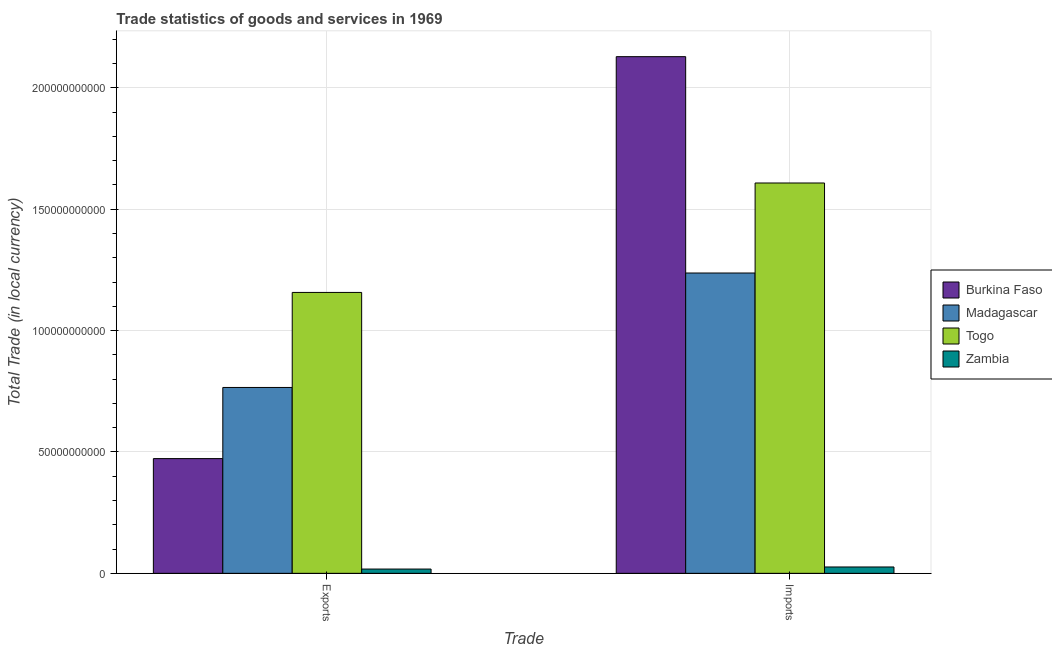How many different coloured bars are there?
Provide a succinct answer. 4. How many groups of bars are there?
Your answer should be compact. 2. How many bars are there on the 2nd tick from the left?
Give a very brief answer. 4. What is the label of the 2nd group of bars from the left?
Make the answer very short. Imports. What is the export of goods and services in Zambia?
Give a very brief answer. 1.76e+09. Across all countries, what is the maximum export of goods and services?
Give a very brief answer. 1.16e+11. Across all countries, what is the minimum export of goods and services?
Ensure brevity in your answer.  1.76e+09. In which country was the imports of goods and services maximum?
Make the answer very short. Burkina Faso. In which country was the imports of goods and services minimum?
Your response must be concise. Zambia. What is the total export of goods and services in the graph?
Keep it short and to the point. 2.41e+11. What is the difference between the imports of goods and services in Togo and that in Madagascar?
Give a very brief answer. 3.71e+1. What is the difference between the imports of goods and services in Togo and the export of goods and services in Zambia?
Provide a short and direct response. 1.59e+11. What is the average imports of goods and services per country?
Ensure brevity in your answer.  1.25e+11. What is the difference between the export of goods and services and imports of goods and services in Madagascar?
Ensure brevity in your answer.  -4.72e+1. What is the ratio of the imports of goods and services in Burkina Faso to that in Madagascar?
Provide a short and direct response. 1.72. In how many countries, is the imports of goods and services greater than the average imports of goods and services taken over all countries?
Your answer should be compact. 2. What does the 3rd bar from the left in Imports represents?
Offer a terse response. Togo. What does the 2nd bar from the right in Imports represents?
Offer a very short reply. Togo. How many bars are there?
Make the answer very short. 8. Are all the bars in the graph horizontal?
Provide a short and direct response. No. How many countries are there in the graph?
Provide a succinct answer. 4. What is the difference between two consecutive major ticks on the Y-axis?
Ensure brevity in your answer.  5.00e+1. Where does the legend appear in the graph?
Offer a terse response. Center right. How many legend labels are there?
Give a very brief answer. 4. What is the title of the graph?
Your response must be concise. Trade statistics of goods and services in 1969. What is the label or title of the X-axis?
Your response must be concise. Trade. What is the label or title of the Y-axis?
Make the answer very short. Total Trade (in local currency). What is the Total Trade (in local currency) of Burkina Faso in Exports?
Your answer should be very brief. 4.73e+1. What is the Total Trade (in local currency) in Madagascar in Exports?
Keep it short and to the point. 7.66e+1. What is the Total Trade (in local currency) of Togo in Exports?
Provide a succinct answer. 1.16e+11. What is the Total Trade (in local currency) of Zambia in Exports?
Provide a succinct answer. 1.76e+09. What is the Total Trade (in local currency) of Burkina Faso in Imports?
Your answer should be compact. 2.13e+11. What is the Total Trade (in local currency) in Madagascar in Imports?
Provide a short and direct response. 1.24e+11. What is the Total Trade (in local currency) of Togo in Imports?
Keep it short and to the point. 1.61e+11. What is the Total Trade (in local currency) of Zambia in Imports?
Your answer should be very brief. 2.62e+09. Across all Trade, what is the maximum Total Trade (in local currency) of Burkina Faso?
Your response must be concise. 2.13e+11. Across all Trade, what is the maximum Total Trade (in local currency) in Madagascar?
Your answer should be compact. 1.24e+11. Across all Trade, what is the maximum Total Trade (in local currency) in Togo?
Your answer should be compact. 1.61e+11. Across all Trade, what is the maximum Total Trade (in local currency) in Zambia?
Offer a very short reply. 2.62e+09. Across all Trade, what is the minimum Total Trade (in local currency) in Burkina Faso?
Your answer should be compact. 4.73e+1. Across all Trade, what is the minimum Total Trade (in local currency) of Madagascar?
Provide a succinct answer. 7.66e+1. Across all Trade, what is the minimum Total Trade (in local currency) of Togo?
Your answer should be compact. 1.16e+11. Across all Trade, what is the minimum Total Trade (in local currency) of Zambia?
Your answer should be compact. 1.76e+09. What is the total Total Trade (in local currency) of Burkina Faso in the graph?
Your response must be concise. 2.60e+11. What is the total Total Trade (in local currency) in Madagascar in the graph?
Keep it short and to the point. 2.00e+11. What is the total Total Trade (in local currency) in Togo in the graph?
Your answer should be compact. 2.77e+11. What is the total Total Trade (in local currency) of Zambia in the graph?
Offer a very short reply. 4.38e+09. What is the difference between the Total Trade (in local currency) in Burkina Faso in Exports and that in Imports?
Offer a terse response. -1.66e+11. What is the difference between the Total Trade (in local currency) in Madagascar in Exports and that in Imports?
Your answer should be compact. -4.72e+1. What is the difference between the Total Trade (in local currency) in Togo in Exports and that in Imports?
Make the answer very short. -4.51e+1. What is the difference between the Total Trade (in local currency) of Zambia in Exports and that in Imports?
Your answer should be compact. -8.61e+08. What is the difference between the Total Trade (in local currency) in Burkina Faso in Exports and the Total Trade (in local currency) in Madagascar in Imports?
Provide a succinct answer. -7.65e+1. What is the difference between the Total Trade (in local currency) in Burkina Faso in Exports and the Total Trade (in local currency) in Togo in Imports?
Keep it short and to the point. -1.14e+11. What is the difference between the Total Trade (in local currency) in Burkina Faso in Exports and the Total Trade (in local currency) in Zambia in Imports?
Your answer should be compact. 4.46e+1. What is the difference between the Total Trade (in local currency) of Madagascar in Exports and the Total Trade (in local currency) of Togo in Imports?
Provide a succinct answer. -8.42e+1. What is the difference between the Total Trade (in local currency) of Madagascar in Exports and the Total Trade (in local currency) of Zambia in Imports?
Ensure brevity in your answer.  7.39e+1. What is the difference between the Total Trade (in local currency) of Togo in Exports and the Total Trade (in local currency) of Zambia in Imports?
Provide a short and direct response. 1.13e+11. What is the average Total Trade (in local currency) in Burkina Faso per Trade?
Make the answer very short. 1.30e+11. What is the average Total Trade (in local currency) of Madagascar per Trade?
Keep it short and to the point. 1.00e+11. What is the average Total Trade (in local currency) of Togo per Trade?
Your answer should be compact. 1.38e+11. What is the average Total Trade (in local currency) of Zambia per Trade?
Make the answer very short. 2.19e+09. What is the difference between the Total Trade (in local currency) of Burkina Faso and Total Trade (in local currency) of Madagascar in Exports?
Give a very brief answer. -2.93e+1. What is the difference between the Total Trade (in local currency) in Burkina Faso and Total Trade (in local currency) in Togo in Exports?
Keep it short and to the point. -6.85e+1. What is the difference between the Total Trade (in local currency) in Burkina Faso and Total Trade (in local currency) in Zambia in Exports?
Give a very brief answer. 4.55e+1. What is the difference between the Total Trade (in local currency) of Madagascar and Total Trade (in local currency) of Togo in Exports?
Your answer should be compact. -3.91e+1. What is the difference between the Total Trade (in local currency) of Madagascar and Total Trade (in local currency) of Zambia in Exports?
Offer a very short reply. 7.48e+1. What is the difference between the Total Trade (in local currency) in Togo and Total Trade (in local currency) in Zambia in Exports?
Your answer should be very brief. 1.14e+11. What is the difference between the Total Trade (in local currency) in Burkina Faso and Total Trade (in local currency) in Madagascar in Imports?
Make the answer very short. 8.91e+1. What is the difference between the Total Trade (in local currency) in Burkina Faso and Total Trade (in local currency) in Togo in Imports?
Offer a very short reply. 5.20e+1. What is the difference between the Total Trade (in local currency) of Burkina Faso and Total Trade (in local currency) of Zambia in Imports?
Provide a succinct answer. 2.10e+11. What is the difference between the Total Trade (in local currency) of Madagascar and Total Trade (in local currency) of Togo in Imports?
Your answer should be compact. -3.71e+1. What is the difference between the Total Trade (in local currency) of Madagascar and Total Trade (in local currency) of Zambia in Imports?
Provide a short and direct response. 1.21e+11. What is the difference between the Total Trade (in local currency) in Togo and Total Trade (in local currency) in Zambia in Imports?
Offer a very short reply. 1.58e+11. What is the ratio of the Total Trade (in local currency) in Burkina Faso in Exports to that in Imports?
Offer a very short reply. 0.22. What is the ratio of the Total Trade (in local currency) in Madagascar in Exports to that in Imports?
Make the answer very short. 0.62. What is the ratio of the Total Trade (in local currency) in Togo in Exports to that in Imports?
Give a very brief answer. 0.72. What is the ratio of the Total Trade (in local currency) of Zambia in Exports to that in Imports?
Offer a very short reply. 0.67. What is the difference between the highest and the second highest Total Trade (in local currency) in Burkina Faso?
Provide a succinct answer. 1.66e+11. What is the difference between the highest and the second highest Total Trade (in local currency) of Madagascar?
Ensure brevity in your answer.  4.72e+1. What is the difference between the highest and the second highest Total Trade (in local currency) of Togo?
Give a very brief answer. 4.51e+1. What is the difference between the highest and the second highest Total Trade (in local currency) of Zambia?
Your response must be concise. 8.61e+08. What is the difference between the highest and the lowest Total Trade (in local currency) in Burkina Faso?
Provide a succinct answer. 1.66e+11. What is the difference between the highest and the lowest Total Trade (in local currency) of Madagascar?
Keep it short and to the point. 4.72e+1. What is the difference between the highest and the lowest Total Trade (in local currency) of Togo?
Provide a succinct answer. 4.51e+1. What is the difference between the highest and the lowest Total Trade (in local currency) in Zambia?
Your answer should be very brief. 8.61e+08. 